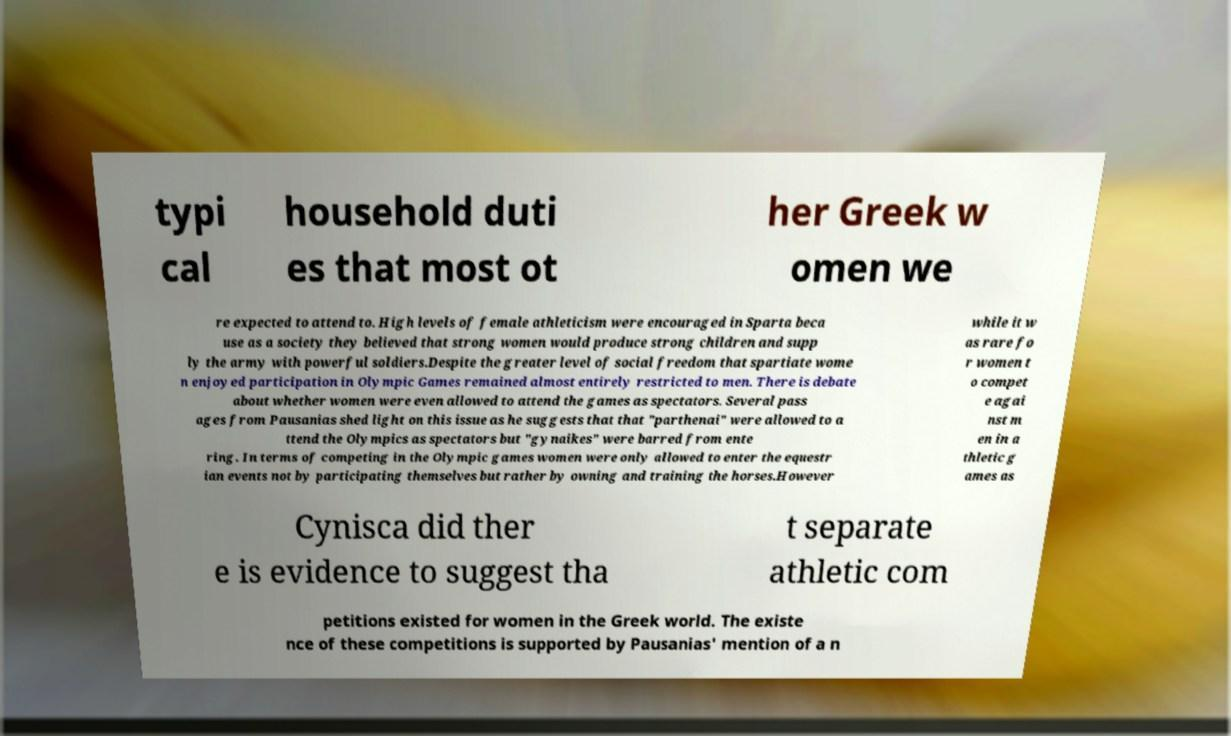Could you extract and type out the text from this image? typi cal household duti es that most ot her Greek w omen we re expected to attend to. High levels of female athleticism were encouraged in Sparta beca use as a society they believed that strong women would produce strong children and supp ly the army with powerful soldiers.Despite the greater level of social freedom that spartiate wome n enjoyed participation in Olympic Games remained almost entirely restricted to men. There is debate about whether women were even allowed to attend the games as spectators. Several pass ages from Pausanias shed light on this issue as he suggests that that "parthenai" were allowed to a ttend the Olympics as spectators but "gynaikes" were barred from ente ring. In terms of competing in the Olympic games women were only allowed to enter the equestr ian events not by participating themselves but rather by owning and training the horses.However while it w as rare fo r women t o compet e agai nst m en in a thletic g ames as Cynisca did ther e is evidence to suggest tha t separate athletic com petitions existed for women in the Greek world. The existe nce of these competitions is supported by Pausanias' mention of a n 